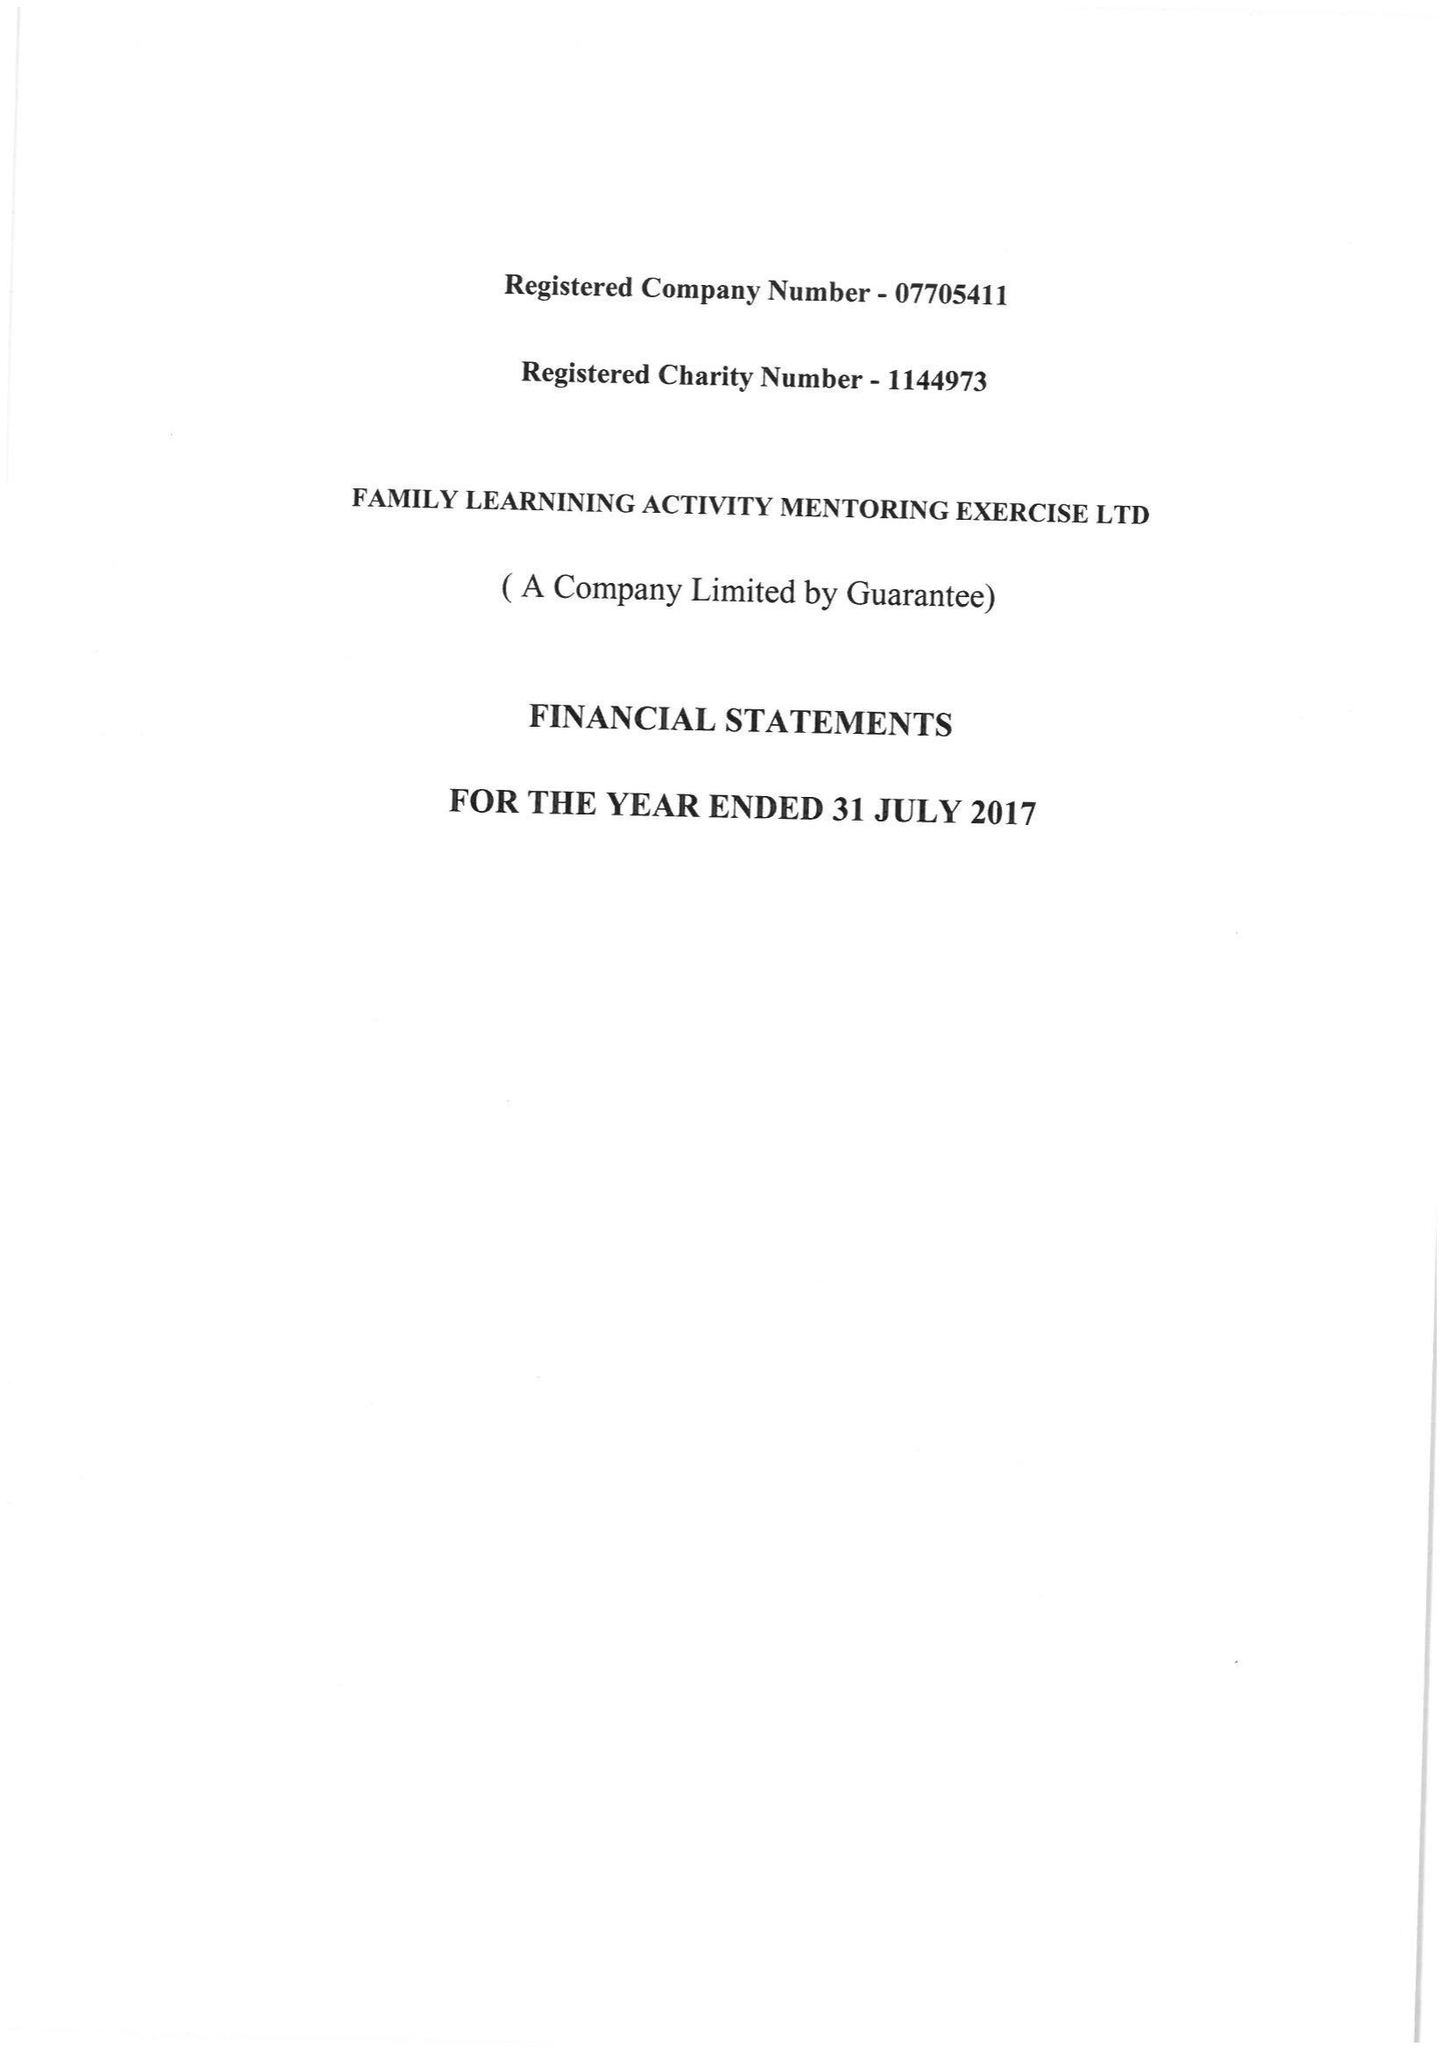What is the value for the income_annually_in_british_pounds?
Answer the question using a single word or phrase. 26299.00 